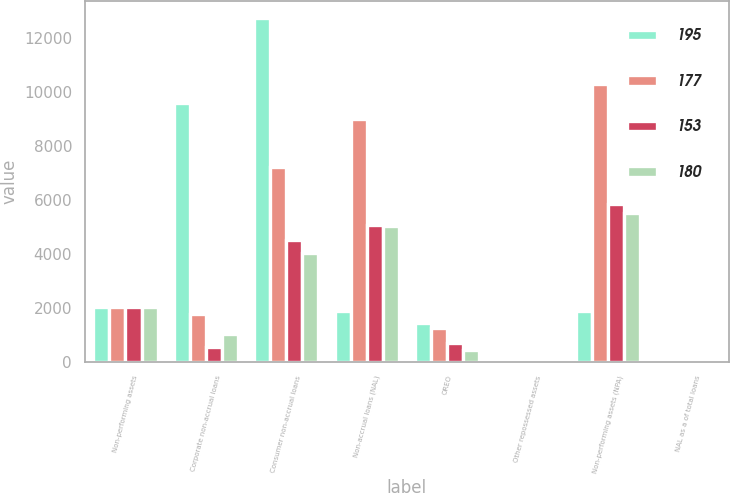Convert chart. <chart><loc_0><loc_0><loc_500><loc_500><stacked_bar_chart><ecel><fcel>Non-performing assets<fcel>Corporate non-accrual loans<fcel>Consumer non-accrual loans<fcel>Non-accrual loans (NAL)<fcel>OREO<fcel>Other repossessed assets<fcel>Non-performing assets (NPA)<fcel>NAL as a of total loans<nl><fcel>195<fcel>2008<fcel>9569<fcel>12728<fcel>1881.5<fcel>1433<fcel>78<fcel>1881.5<fcel>3.21<nl><fcel>177<fcel>2007<fcel>1758<fcel>7210<fcel>8968<fcel>1228<fcel>99<fcel>10295<fcel>1.15<nl><fcel>153<fcel>2006<fcel>535<fcel>4512<fcel>5047<fcel>701<fcel>75<fcel>5823<fcel>0.74<nl><fcel>180<fcel>2005<fcel>1004<fcel>4020<fcel>5024<fcel>429<fcel>62<fcel>5515<fcel>0.86<nl></chart> 